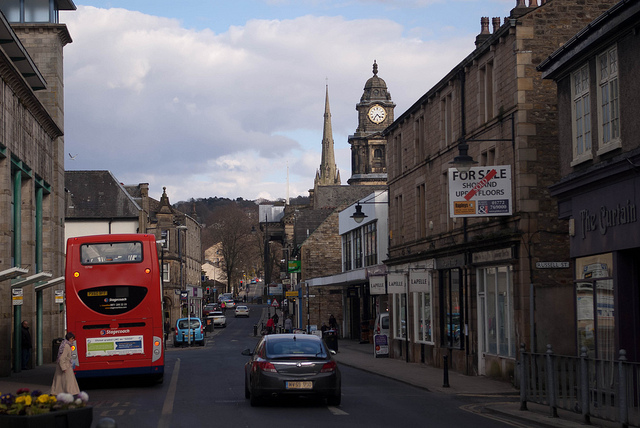<image>What kind of sign is in the middle of the road? It is unknown what kind of sign it is as there are mixed responses like 'for sale', 'bus', 'license plate', and 'traffic'. What sign is the graffiti on? It is unclear what sign the graffiti is on. It could be a 'for sale' sign. What sign is the graffiti on? The graffiti is on the "for sale" sign. What kind of sign is in the middle of the road? I am not sure what kind of sign is in the middle of the road. It can be seen 'for sale', 'bus', 'license plate' or 'traffic'. 